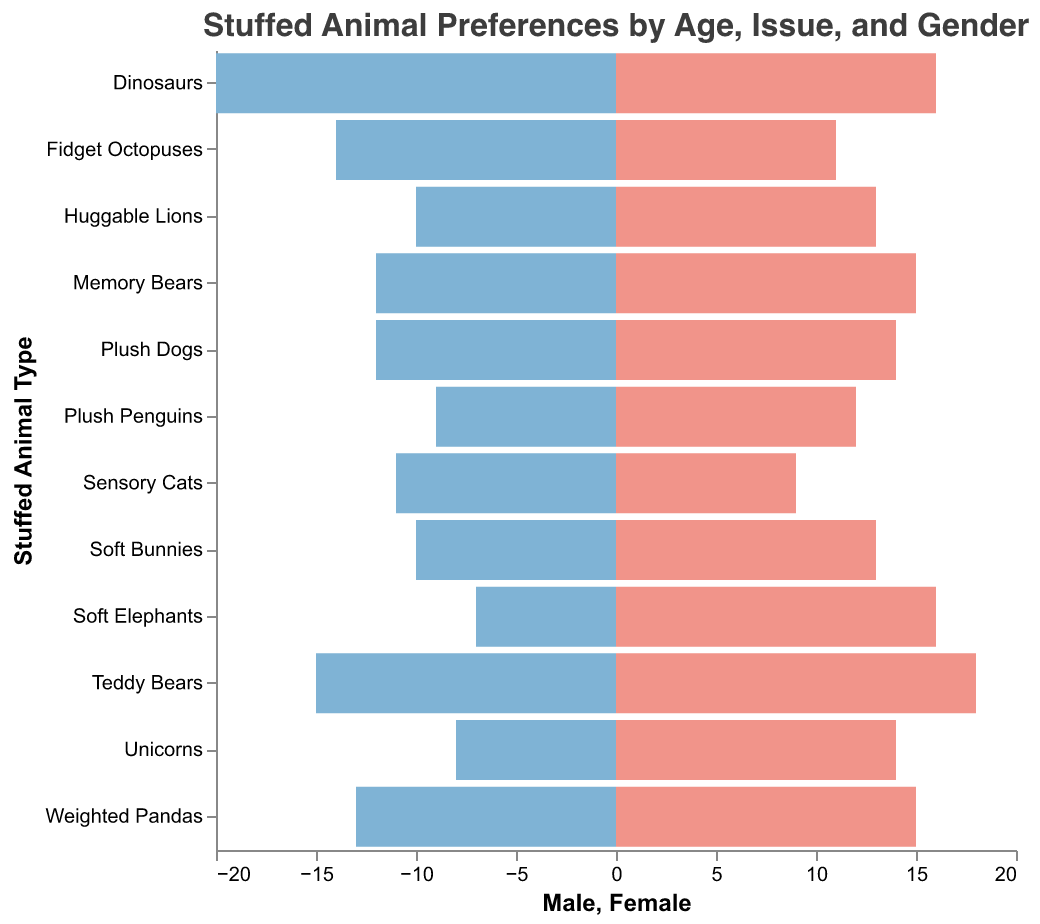What Age Group and Psychological Issue has the highest preference for Teddy Bears? To find this, look under the "Age Group" and "Psychological Issue" columns for the rows with "Teddy Bears". The data shows that the highest values for male and female preferences in Teddy Bears are within the "3-5" age group and for the psychological issue of "Anxiety."
Answer: "3-5", "Anxiety" What is the most preferred stuffed animal type among females aged 12-14? Within the "12-14" age group, analyze the female preference columns for various stuffed animal types. The highest value among females in this age group is 16 for "Soft Elephants," associated with "Eating Disorders."
Answer: Soft Elephants Which Psychological Issue correlates with the highest preference for Dinosaurs? Check the data for "Dinosaurs" and note the corresponding Psychological Issue. "Dinosaurs" have the highest preference in the 6-8 age group for ADHD, with 20 males and 16 females favoring them.
Answer: ADHD Compare the preference for Huggable Lions between males and females aged 12-14. Who has a higher preference? Find the "12-14" age group and locate the row for "Huggable Lions." Compare the male (10) and female (13) columns. Females have a higher preference than males.
Answer: Females What stuffed animal type has equal or nearly equal preferences between males and females? Scan through the data to find the stuffed animal types where the male and female preferences are close in number. "Sensory Cats," associated with the 6-8 age group and Autism Spectrum, has 11 males and 9 females, showing near equality.
Answer: Sensory Cats What are the total preferences for Soft Bunnies among 3-5 year-olds with Sleep Disorders? Add the male and female values for "Soft Bunnies" under the "3-5" age group and "Sleep Disorders." The values are 10 males and 13 females, resulting in a total of 23.
Answer: 23 In the 9-11 age group, which plush animal has the highest preference among children with Trauma? Check the "9-11" age group and look for the "Trauma" psychological issue. The row shows "Weighted Pandas" with 13 males and 15 females, making it the highest preference.
Answer: Weighted Pandas What is the ratio of males to females preferring Weighted Pandas in the 9-11 age group with Trauma? Calculate the ratio using 13 males and 15 females. The ratio is 13:15, which simplifies to around 0.87:1.
Answer: 0.87:1 Between the ages 3-5 and 12-14, what is the trend in preference for Soft Bunnies? Look at the data for "Soft Bunnies" in the "3-5" age group and note the preferences, then see if there are any preferences in the "12-14" age group, noting that Soft Bunnies are not present in the older group. This indicates a decline as children age.
Answer: Decline Which gender shows a higher preference for Plush Penguins among children with Social Phobia in the 9-11 age group? For the "9-11" age group and "Social Phobia," compare the male (9) and female (12) preferences for "Plush Penguins." Females show a higher preference.
Answer: Females 